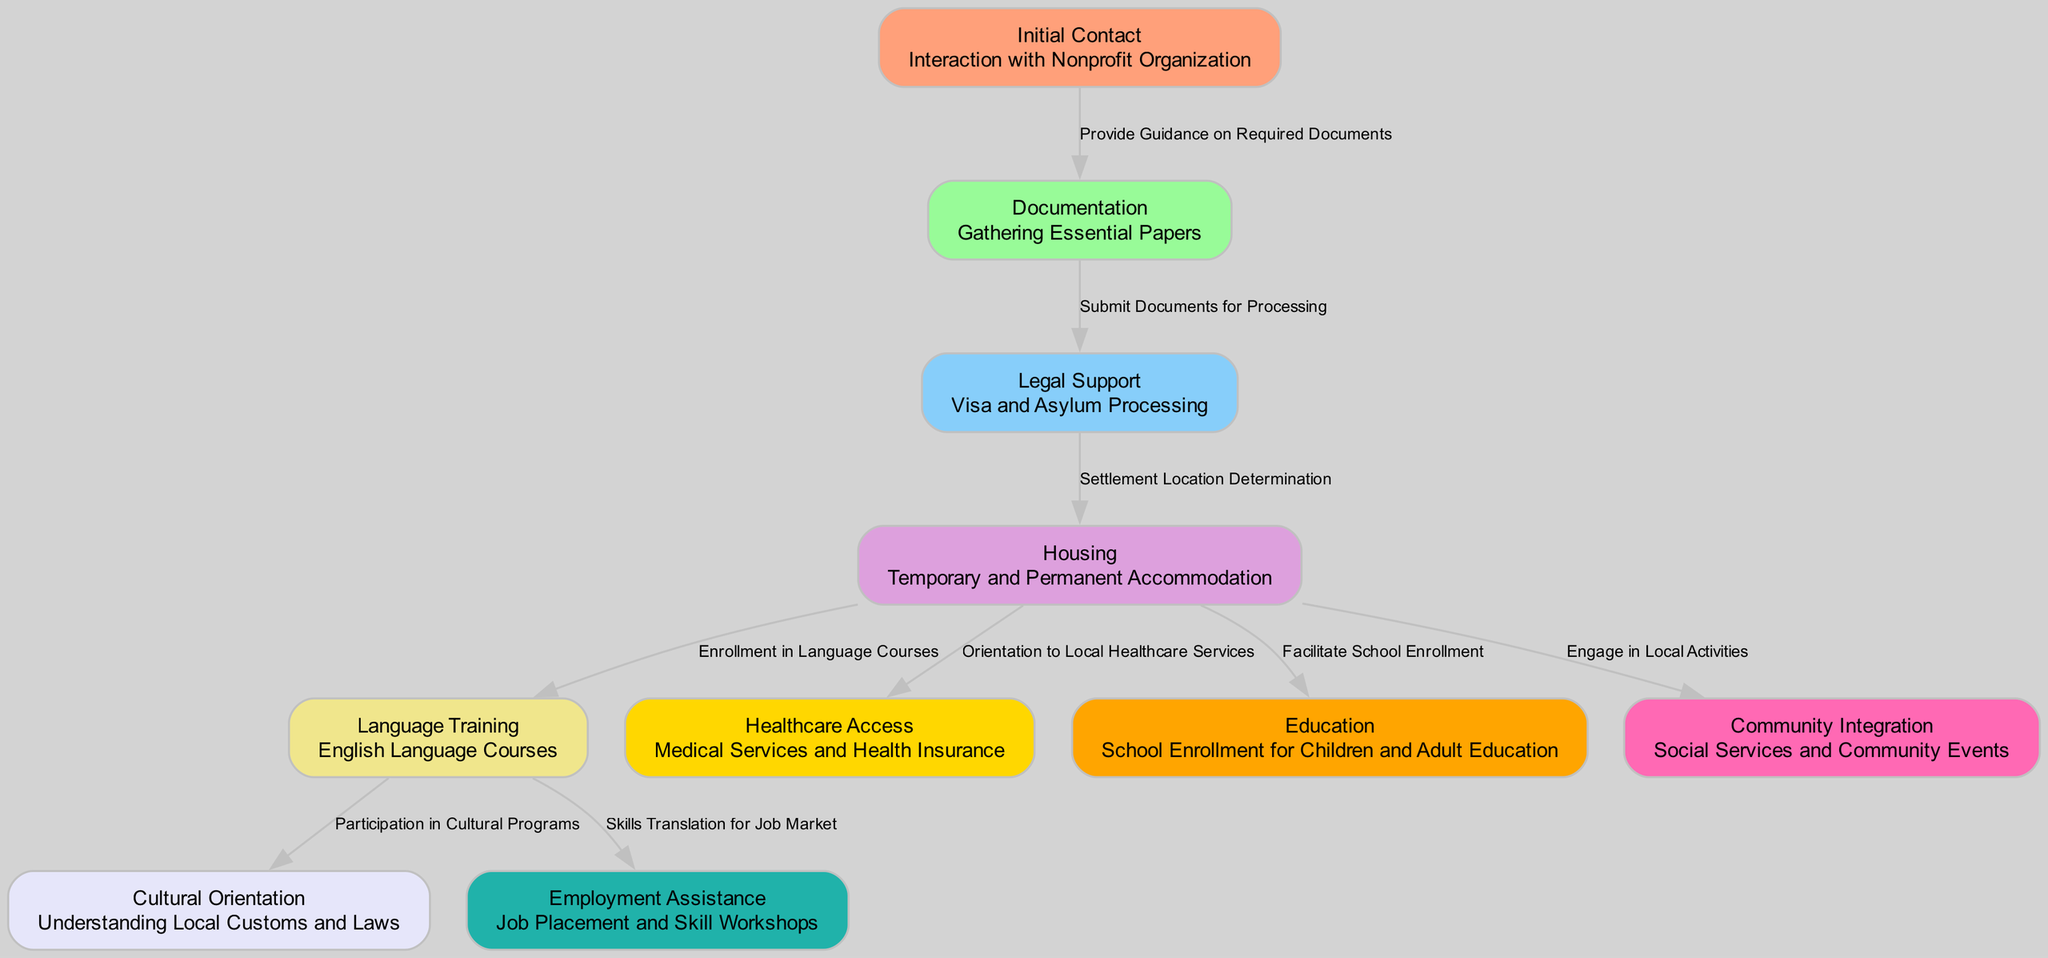What is the first step in the resettlement process? The first step, as indicated in the diagram, is "Initial Contact" with the Nonprofit Organization, which is the starting point of the resettlement process.
Answer: Initial Contact How many nodes are present in the diagram? By counting the individual elements listed, there are a total of 11 nodes representing different steps in the resettlement process.
Answer: 11 What is the relationship between "Documentation" and "Legal Support"? The diagram shows that the relationship between "Documentation" and "Legal Support" is "Submit Documents for Processing," indicating that proper documentation is necessary for legal processes.
Answer: Submit Documents for Processing What follows "Housing" in the integration process? According to the diagram, after "Housing," the next steps include "Language Training," "Healthcare Access," "Education," and "Community Integration," showing various areas of support.
Answer: Language Training, Healthcare Access, Education, Community Integration Which node is related to both "Housing" and "Healthcare Access"? The node "Housing" is directly connected to "Healthcare Access" through the relationship "Orientation to Local Healthcare Services," indicating that housing is linked to access to healthcare resources.
Answer: Healthcare Access How does "Language Training" connect to "Employment Assistance"? The diagram states that "Language Training" to "Employment Assistance" is connected by the relationship "Skills Translation for Job Market," meaning language skills facilitate job opportunities.
Answer: Skills Translation for Job Market How many relationships connect from "Housing"? There are four relationships stemming from "Housing," which connect to "Language Training," "Healthcare Access," "Education," and "Community Integration."
Answer: 4 What type of support follows "Legal Support"? "Housing" follows "Legal Support" as the next step, indicating that the legal processes pave the way for securing accommodation.
Answer: Housing What is the last step mentioned in the integration diagram? The last step mentioned is "Community Integration," which encompasses social services and community events to help individuals feel part of the new society.
Answer: Community Integration 